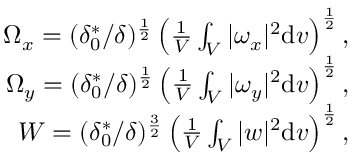Convert formula to latex. <formula><loc_0><loc_0><loc_500><loc_500>\begin{array} { r } { \Omega _ { x } = ( \delta _ { 0 } ^ { * } / \delta ) ^ { \frac { 1 } { 2 } } \left ( \frac { 1 } { V } \int _ { V } | \omega _ { x } | ^ { 2 } \mathrm d v \right ) ^ { \frac { 1 } { 2 } } , } \\ { \Omega _ { y } = ( \delta _ { 0 } ^ { * } / \delta ) ^ { \frac { 1 } { 2 } } \left ( \frac { 1 } { V } \int _ { V } | \omega _ { y } | ^ { 2 } \mathrm d v \right ) ^ { \frac { 1 } { 2 } } , } \\ { W = ( \delta _ { 0 } ^ { * } / \delta ) ^ { \frac { 3 } { 2 } } \left ( \frac { 1 } { V } \int _ { V } | w | ^ { 2 } \mathrm d v \right ) ^ { \frac { 1 } { 2 } } , } \end{array}</formula> 